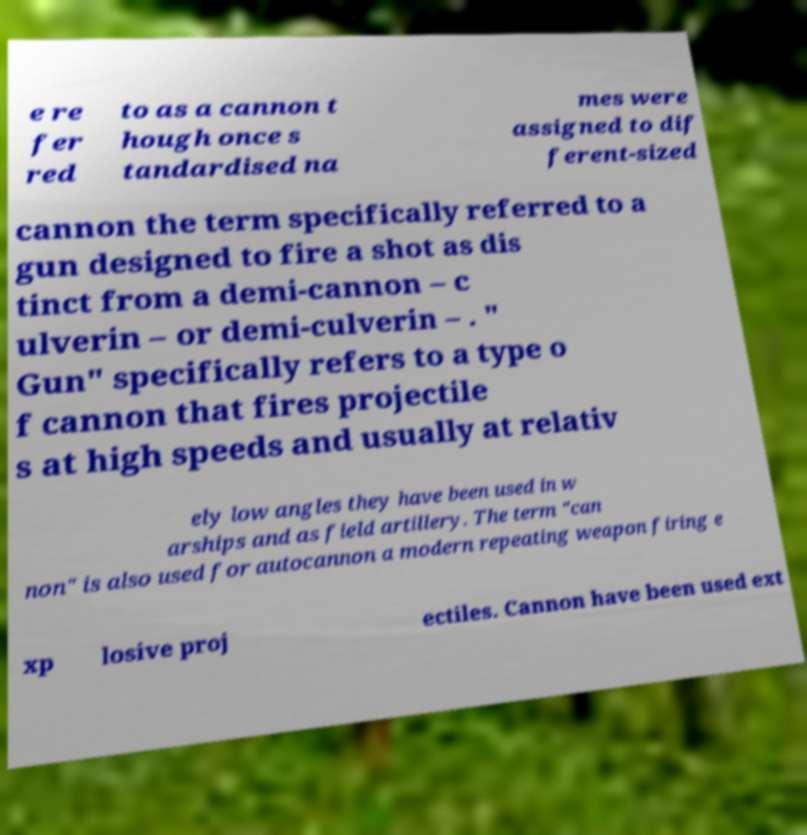Please identify and transcribe the text found in this image. e re fer red to as a cannon t hough once s tandardised na mes were assigned to dif ferent-sized cannon the term specifically referred to a gun designed to fire a shot as dis tinct from a demi-cannon – c ulverin – or demi-culverin – . " Gun" specifically refers to a type o f cannon that fires projectile s at high speeds and usually at relativ ely low angles they have been used in w arships and as field artillery. The term "can non" is also used for autocannon a modern repeating weapon firing e xp losive proj ectiles. Cannon have been used ext 